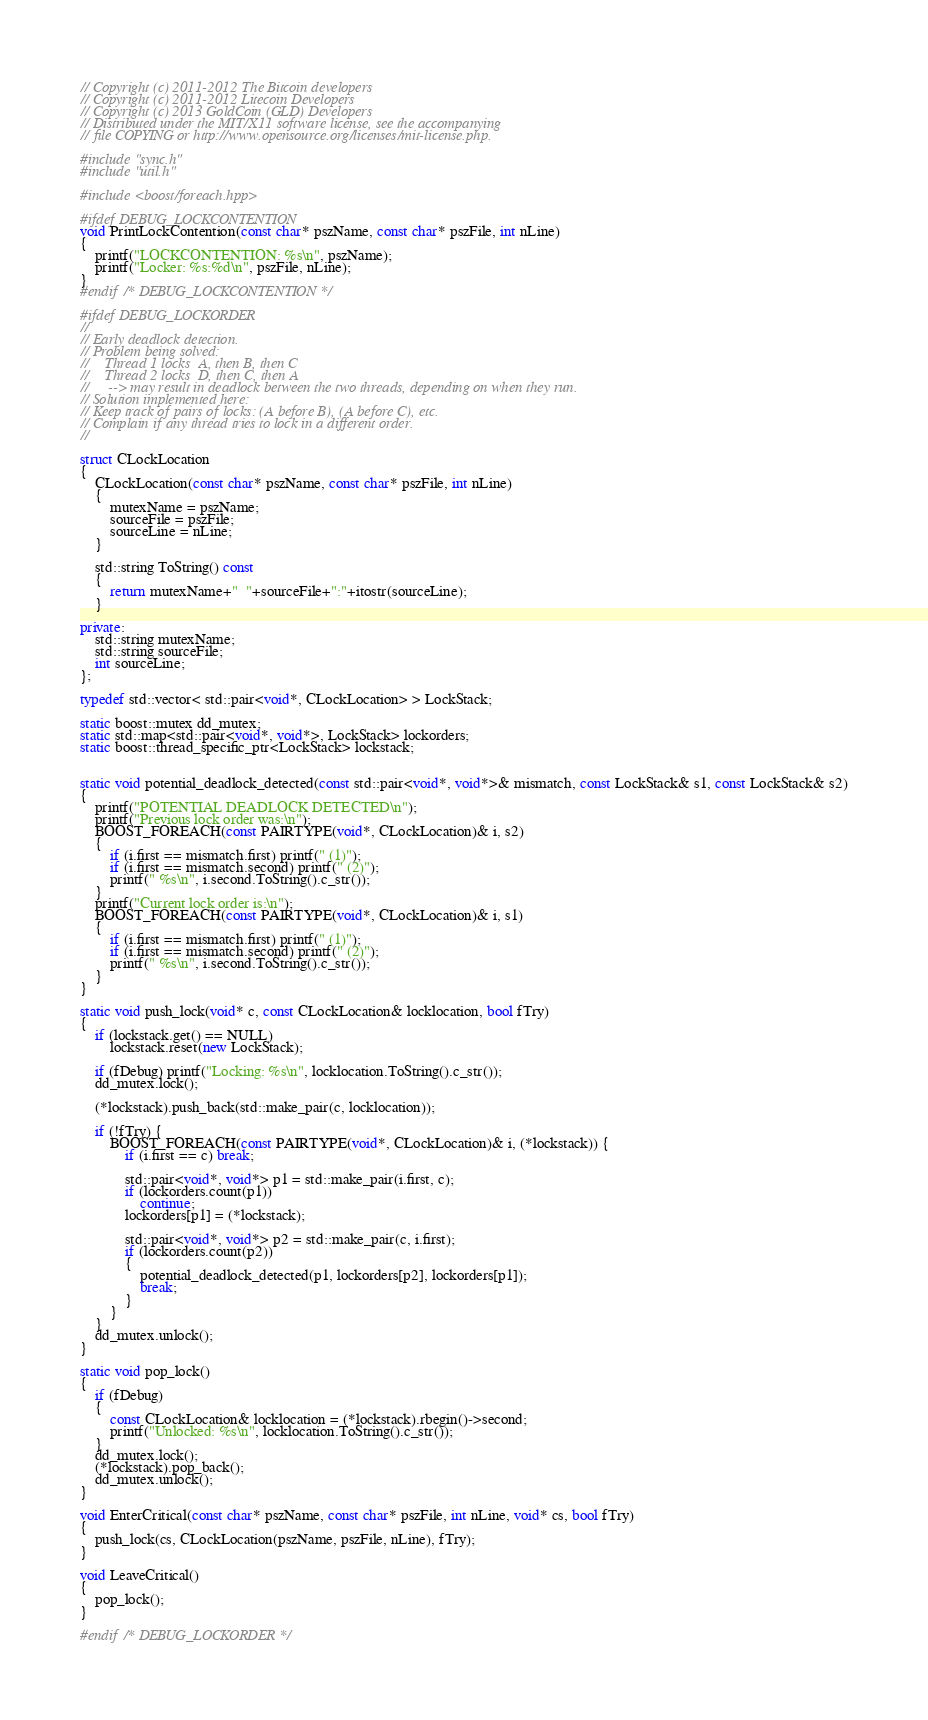Convert code to text. <code><loc_0><loc_0><loc_500><loc_500><_C++_>// Copyright (c) 2011-2012 The Bitcoin developers
// Copyright (c) 2011-2012 Litecoin Developers
// Copyright (c) 2013 GoldCoin (GLD) Developers
// Distributed under the MIT/X11 software license, see the accompanying
// file COPYING or http://www.opensource.org/licenses/mit-license.php.

#include "sync.h"
#include "util.h"

#include <boost/foreach.hpp>

#ifdef DEBUG_LOCKCONTENTION
void PrintLockContention(const char* pszName, const char* pszFile, int nLine)
{
    printf("LOCKCONTENTION: %s\n", pszName);
    printf("Locker: %s:%d\n", pszFile, nLine);
}
#endif /* DEBUG_LOCKCONTENTION */

#ifdef DEBUG_LOCKORDER
//
// Early deadlock detection.
// Problem being solved:
//    Thread 1 locks  A, then B, then C
//    Thread 2 locks  D, then C, then A
//     --> may result in deadlock between the two threads, depending on when they run.
// Solution implemented here:
// Keep track of pairs of locks: (A before B), (A before C), etc.
// Complain if any thread tries to lock in a different order.
//

struct CLockLocation
{
    CLockLocation(const char* pszName, const char* pszFile, int nLine)
    {
        mutexName = pszName;
        sourceFile = pszFile;
        sourceLine = nLine;
    }

    std::string ToString() const
    {
        return mutexName+"  "+sourceFile+":"+itostr(sourceLine);
    }

private:
    std::string mutexName;
    std::string sourceFile;
    int sourceLine;
};

typedef std::vector< std::pair<void*, CLockLocation> > LockStack;

static boost::mutex dd_mutex;
static std::map<std::pair<void*, void*>, LockStack> lockorders;
static boost::thread_specific_ptr<LockStack> lockstack;


static void potential_deadlock_detected(const std::pair<void*, void*>& mismatch, const LockStack& s1, const LockStack& s2)
{
    printf("POTENTIAL DEADLOCK DETECTED\n");
    printf("Previous lock order was:\n");
    BOOST_FOREACH(const PAIRTYPE(void*, CLockLocation)& i, s2)
    {
        if (i.first == mismatch.first) printf(" (1)");
        if (i.first == mismatch.second) printf(" (2)");
        printf(" %s\n", i.second.ToString().c_str());
    }
    printf("Current lock order is:\n");
    BOOST_FOREACH(const PAIRTYPE(void*, CLockLocation)& i, s1)
    {
        if (i.first == mismatch.first) printf(" (1)");
        if (i.first == mismatch.second) printf(" (2)");
        printf(" %s\n", i.second.ToString().c_str());
    }
}

static void push_lock(void* c, const CLockLocation& locklocation, bool fTry)
{
    if (lockstack.get() == NULL)
        lockstack.reset(new LockStack);

    if (fDebug) printf("Locking: %s\n", locklocation.ToString().c_str());
    dd_mutex.lock();

    (*lockstack).push_back(std::make_pair(c, locklocation));

    if (!fTry) {
        BOOST_FOREACH(const PAIRTYPE(void*, CLockLocation)& i, (*lockstack)) {
            if (i.first == c) break;

            std::pair<void*, void*> p1 = std::make_pair(i.first, c);
            if (lockorders.count(p1))
                continue;
            lockorders[p1] = (*lockstack);

            std::pair<void*, void*> p2 = std::make_pair(c, i.first);
            if (lockorders.count(p2))
            {
                potential_deadlock_detected(p1, lockorders[p2], lockorders[p1]);
                break;
            }
        }
    }
    dd_mutex.unlock();
}

static void pop_lock()
{
    if (fDebug) 
    {
        const CLockLocation& locklocation = (*lockstack).rbegin()->second;
        printf("Unlocked: %s\n", locklocation.ToString().c_str());
    }
    dd_mutex.lock();
    (*lockstack).pop_back();
    dd_mutex.unlock();
}

void EnterCritical(const char* pszName, const char* pszFile, int nLine, void* cs, bool fTry)
{
    push_lock(cs, CLockLocation(pszName, pszFile, nLine), fTry);
}

void LeaveCritical()
{
    pop_lock();
}

#endif /* DEBUG_LOCKORDER */
</code> 